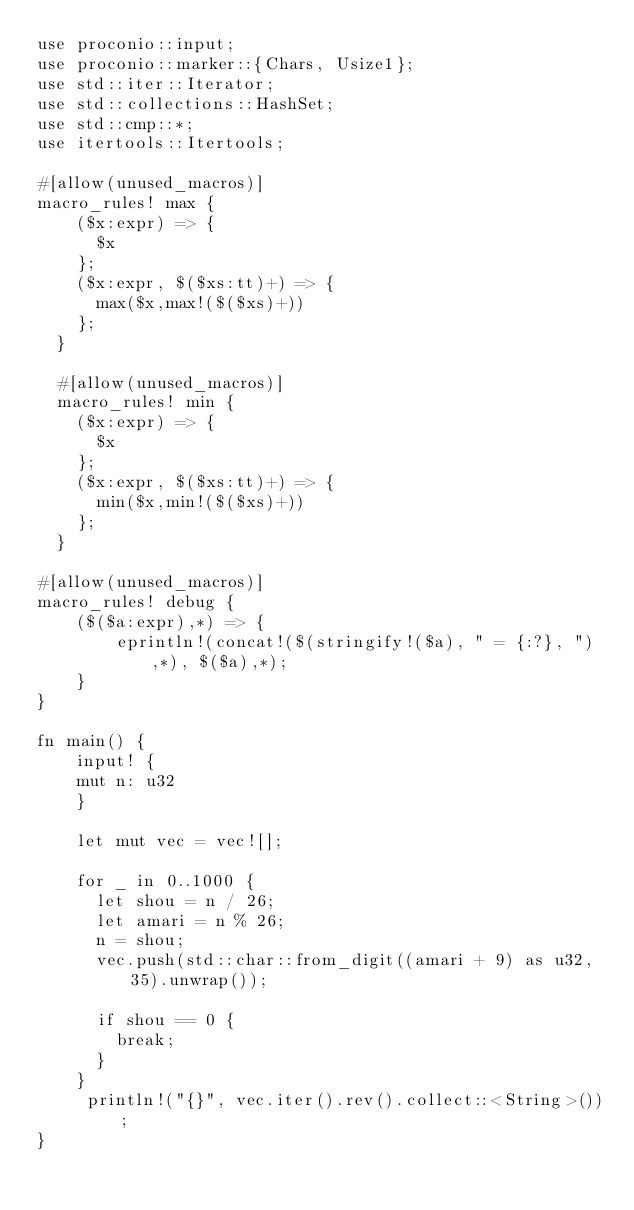<code> <loc_0><loc_0><loc_500><loc_500><_Rust_>use proconio::input;
use proconio::marker::{Chars, Usize1};
use std::iter::Iterator;
use std::collections::HashSet;
use std::cmp::*;
use itertools::Itertools;

#[allow(unused_macros)]
macro_rules! max {
    ($x:expr) => {
      $x
    };
    ($x:expr, $($xs:tt)+) => {
      max($x,max!($($xs)+))
    };
  }
  
  #[allow(unused_macros)]
  macro_rules! min {
    ($x:expr) => {
      $x
    };
    ($x:expr, $($xs:tt)+) => {
      min($x,min!($($xs)+))
    };
  }

#[allow(unused_macros)]
macro_rules! debug {
    ($($a:expr),*) => {
        eprintln!(concat!($(stringify!($a), " = {:?}, "),*), $($a),*);
    }
}

fn main() {
    input! {
    mut n: u32
    }

    let mut vec = vec![];

    for _ in 0..1000 {
      let shou = n / 26;
      let amari = n % 26;
      n = shou;
      vec.push(std::char::from_digit((amari + 9) as u32, 35).unwrap());

      if shou == 0 {
        break;
      }
    }
     println!("{}", vec.iter().rev().collect::<String>());
}
</code> 